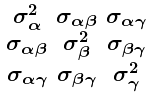<formula> <loc_0><loc_0><loc_500><loc_500>\begin{smallmatrix} \sigma _ { \alpha } ^ { 2 } & \sigma _ { \alpha \beta } & \sigma _ { \alpha \gamma } \\ \sigma _ { \alpha \beta } & \sigma _ { \beta } ^ { 2 } & \sigma _ { \beta \gamma } \\ \sigma _ { \alpha \gamma } & \sigma _ { \beta \gamma } & \sigma _ { \gamma } ^ { 2 } \end{smallmatrix}</formula> 